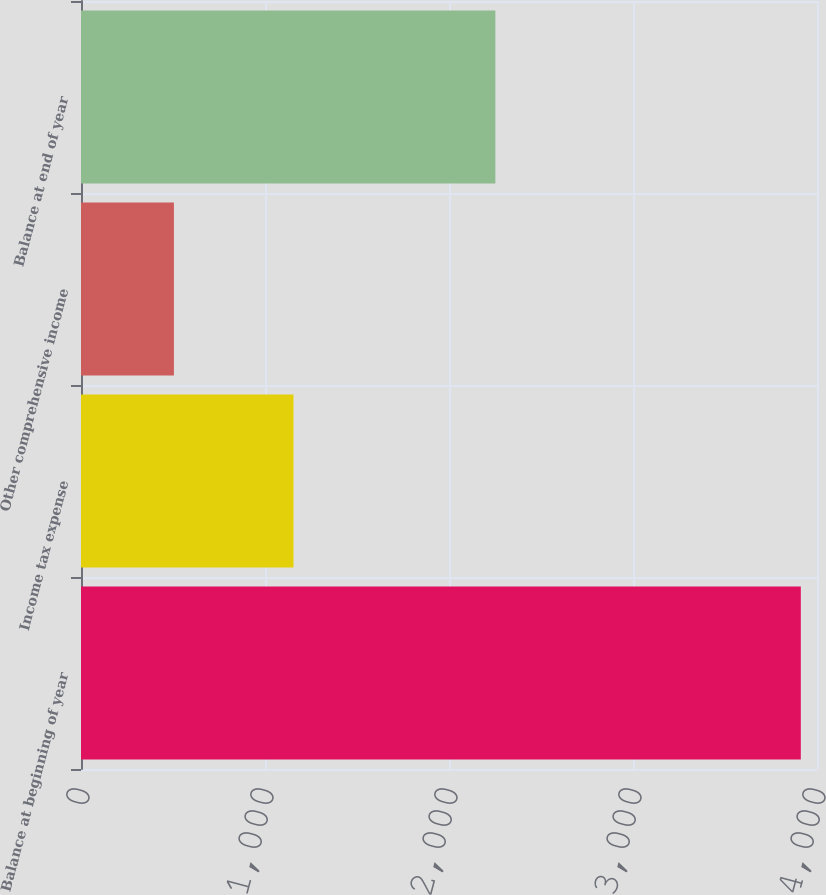Convert chart to OTSL. <chart><loc_0><loc_0><loc_500><loc_500><bar_chart><fcel>Balance at beginning of year<fcel>Income tax expense<fcel>Other comprehensive income<fcel>Balance at end of year<nl><fcel>3912<fcel>1155<fcel>505<fcel>2252<nl></chart> 